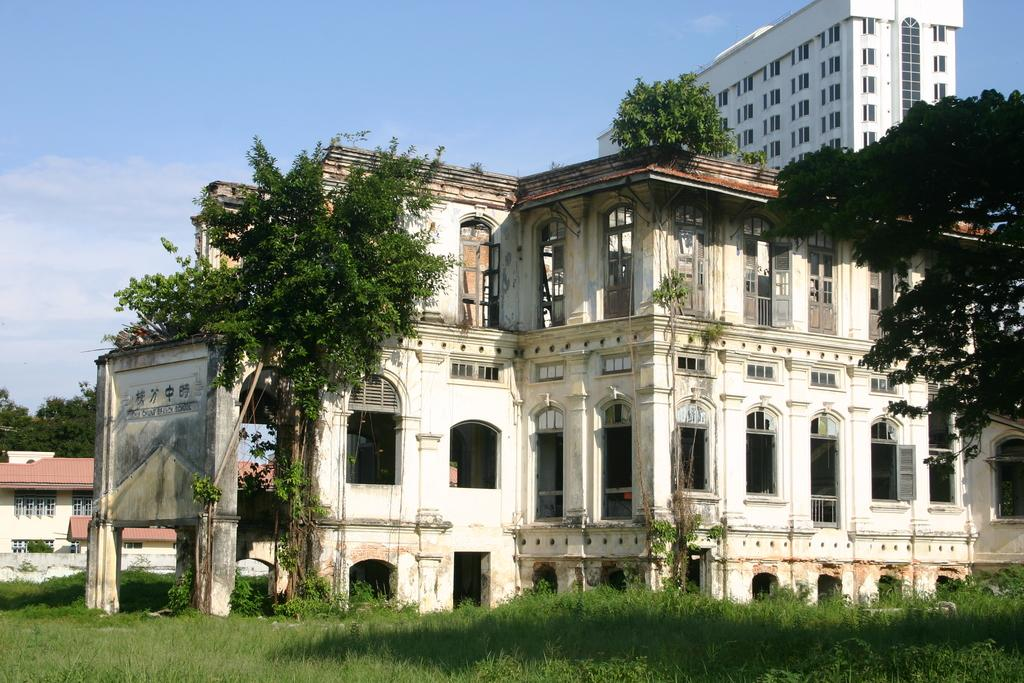What type of structures can be seen in the image? There are buildings in the image. What type of vegetation is present in the image? There are trees and grass in the image. What else can be seen in the image besides buildings and vegetation? There are other objects in the image. What is visible in the background of the image? The sky is visible in the background of the image. How does the mass of the trees affect the heat in the image? There is no information about the mass of the trees or the heat in the image, so it cannot be determined how they might be related. 